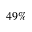<formula> <loc_0><loc_0><loc_500><loc_500>4 9 \%</formula> 